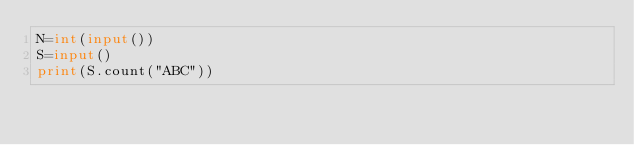Convert code to text. <code><loc_0><loc_0><loc_500><loc_500><_Python_>N=int(input())
S=input()
print(S.count("ABC"))</code> 